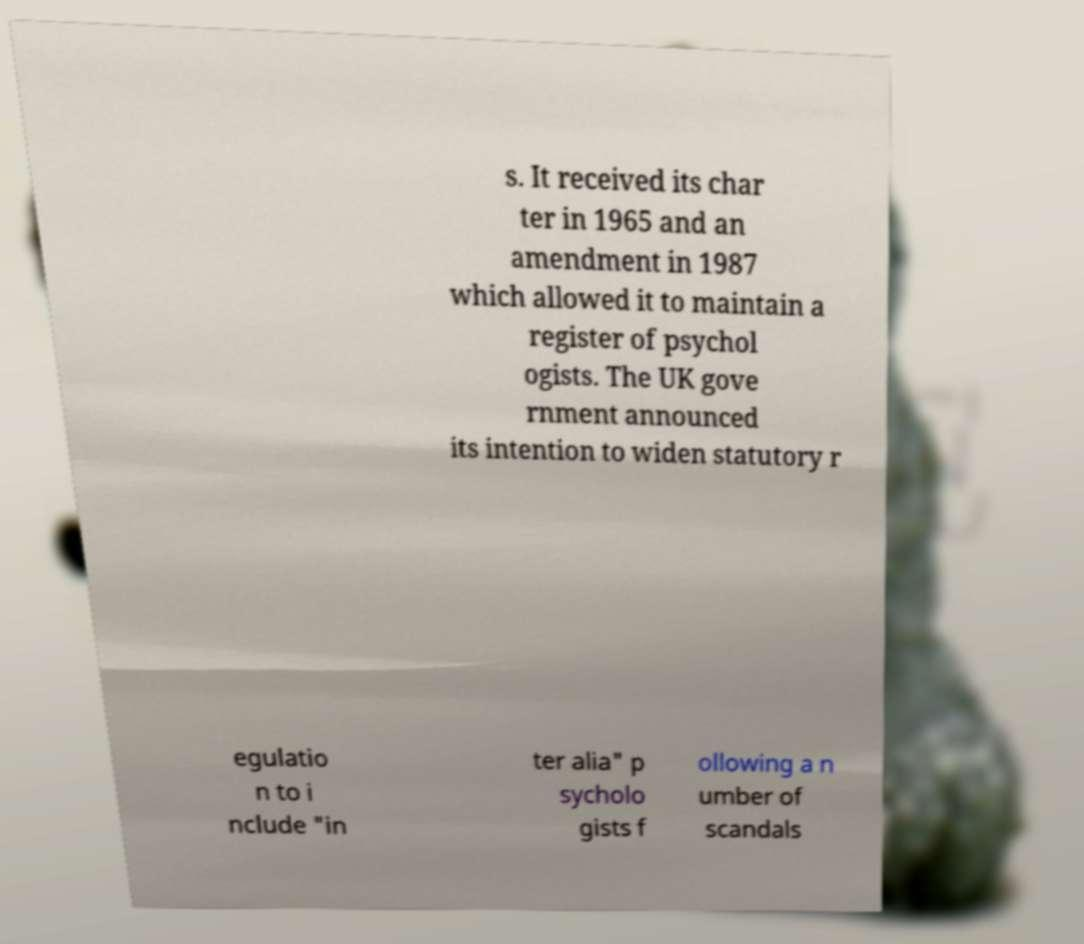I need the written content from this picture converted into text. Can you do that? s. It received its char ter in 1965 and an amendment in 1987 which allowed it to maintain a register of psychol ogists. The UK gove rnment announced its intention to widen statutory r egulatio n to i nclude "in ter alia" p sycholo gists f ollowing a n umber of scandals 